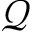<formula> <loc_0><loc_0><loc_500><loc_500>\mathcal { Q }</formula> 